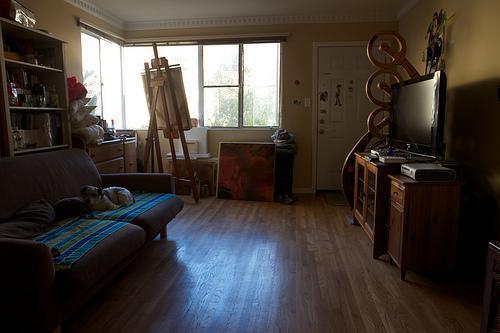How many tvs are there?
Give a very brief answer. 1. 